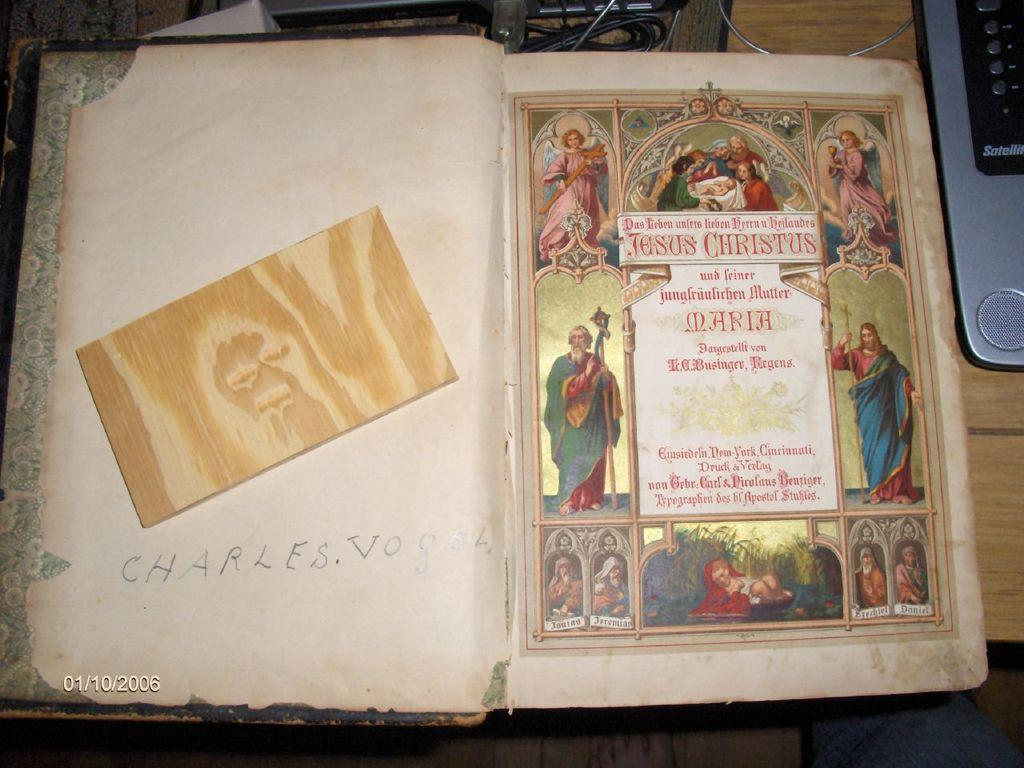<image>
Give a short and clear explanation of the subsequent image. An antique book has the name Charles Vogel written inside the first page. 